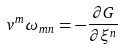Convert formula to latex. <formula><loc_0><loc_0><loc_500><loc_500>v ^ { m } \omega _ { m n } = - \frac { \partial G } { \partial \xi ^ { n } }</formula> 